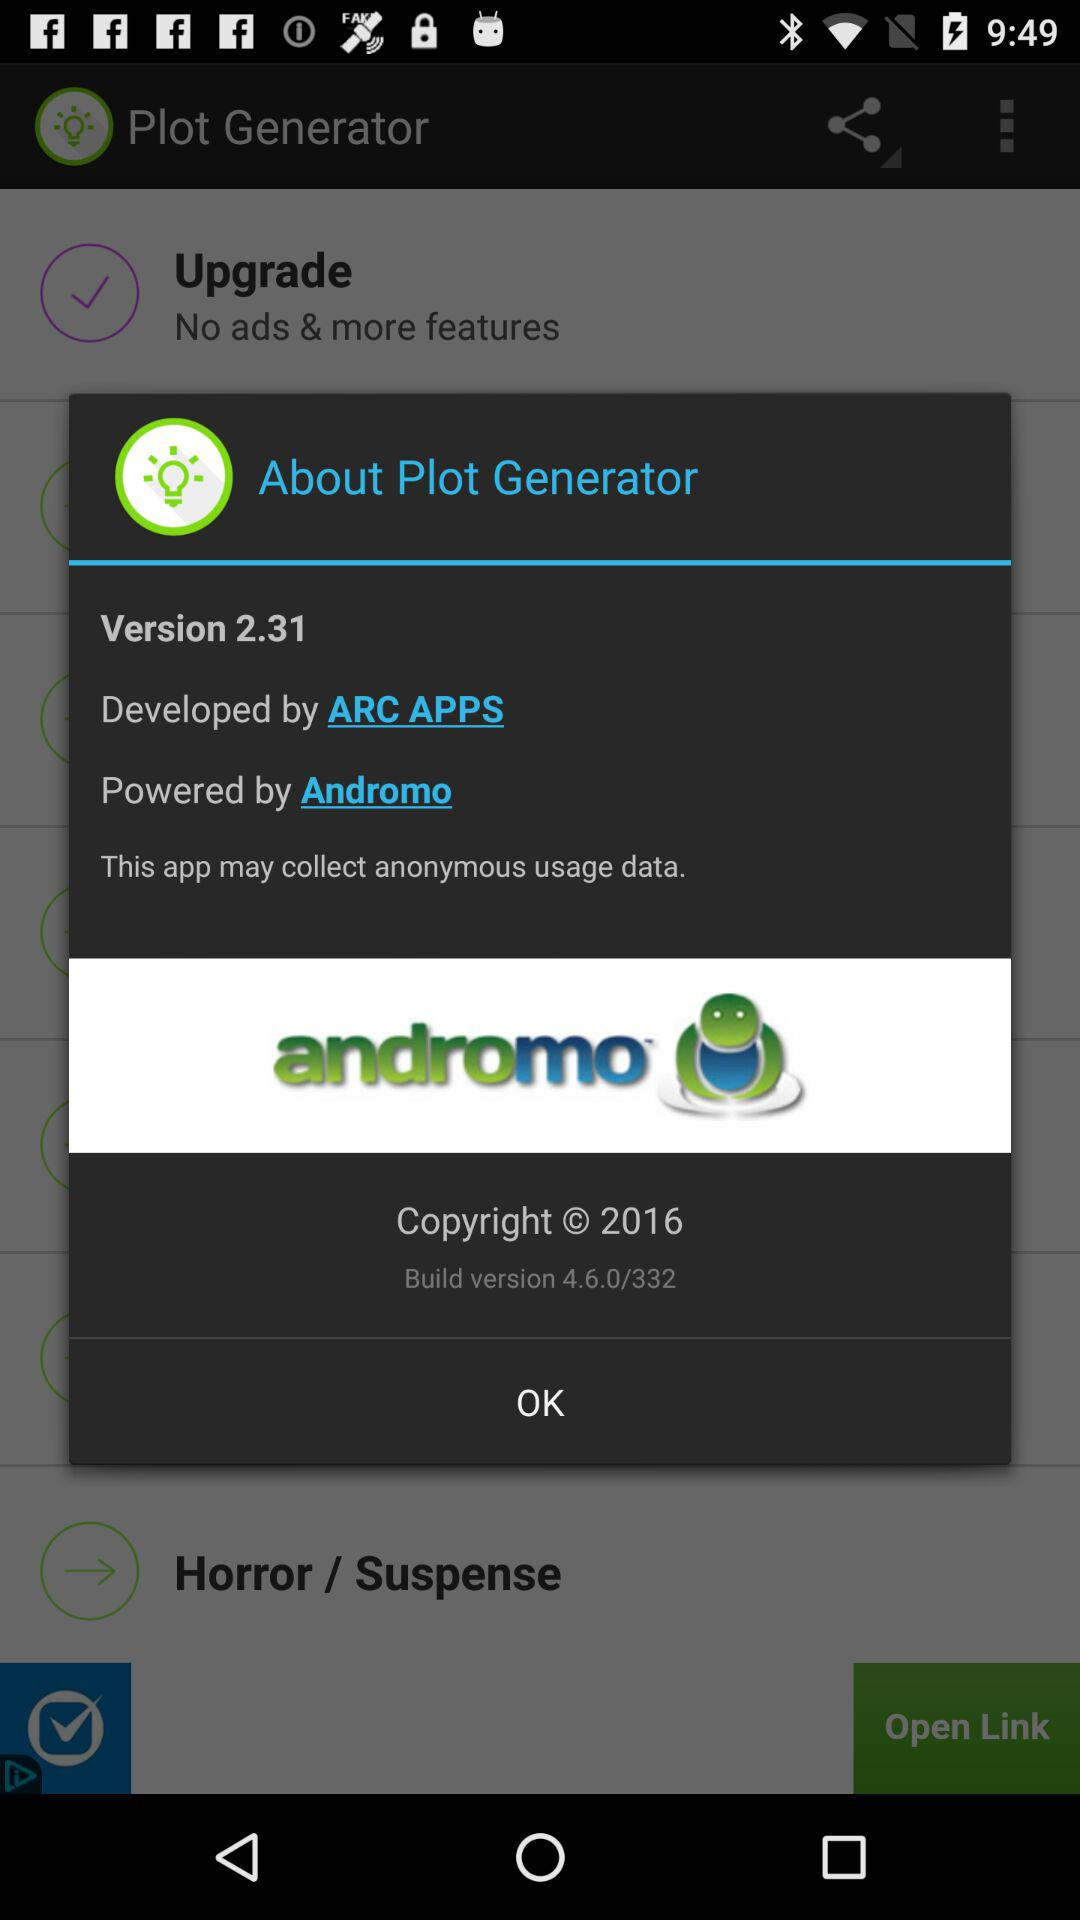What is the build version of this application? The build version of this application is 4.6.0/332. 